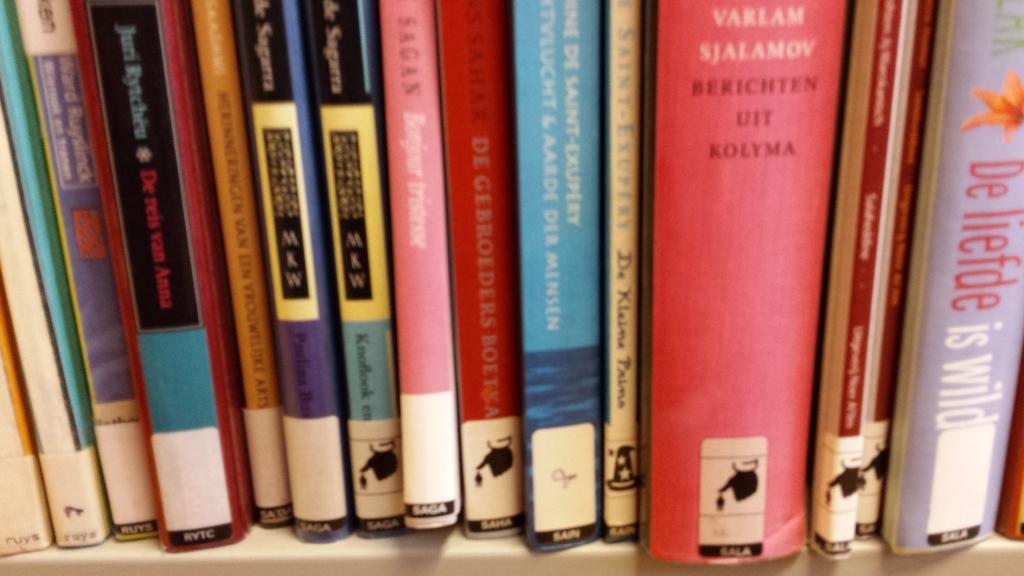What is the book title of the largest red book?
Your answer should be compact. Berichten uit kolyma. 